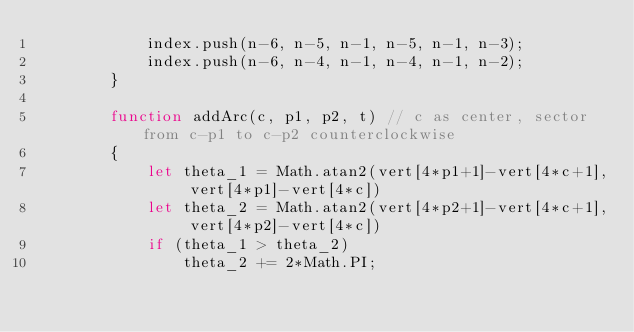<code> <loc_0><loc_0><loc_500><loc_500><_JavaScript_>            index.push(n-6, n-5, n-1, n-5, n-1, n-3);
            index.push(n-6, n-4, n-1, n-4, n-1, n-2);
        }

        function addArc(c, p1, p2, t) // c as center, sector from c-p1 to c-p2 counterclockwise
        {
            let theta_1 = Math.atan2(vert[4*p1+1]-vert[4*c+1], vert[4*p1]-vert[4*c])
            let theta_2 = Math.atan2(vert[4*p2+1]-vert[4*c+1], vert[4*p2]-vert[4*c])
            if (theta_1 > theta_2)
                theta_2 += 2*Math.PI;</code> 